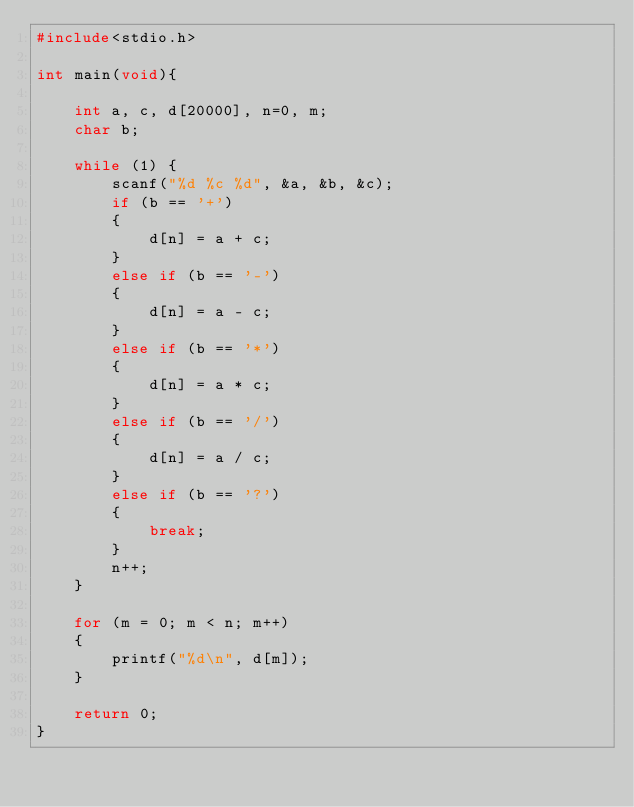<code> <loc_0><loc_0><loc_500><loc_500><_C_>#include<stdio.h>

int main(void){

	int a, c, d[20000], n=0, m;
	char b;

	while (1) {
		scanf("%d %c %d", &a, &b, &c);
		if (b == '+')
		{
			d[n] = a + c;
		}
		else if (b == '-')
		{
			d[n] = a - c;
		}
		else if (b == '*')
		{
			d[n] = a * c;
		}
		else if (b == '/')
		{
			d[n] = a / c;
		}
		else if (b == '?')
		{
			break;
		}
		n++;
	}

	for (m = 0; m < n; m++)
	{
		printf("%d\n", d[m]);
	}

	return 0;
}</code> 